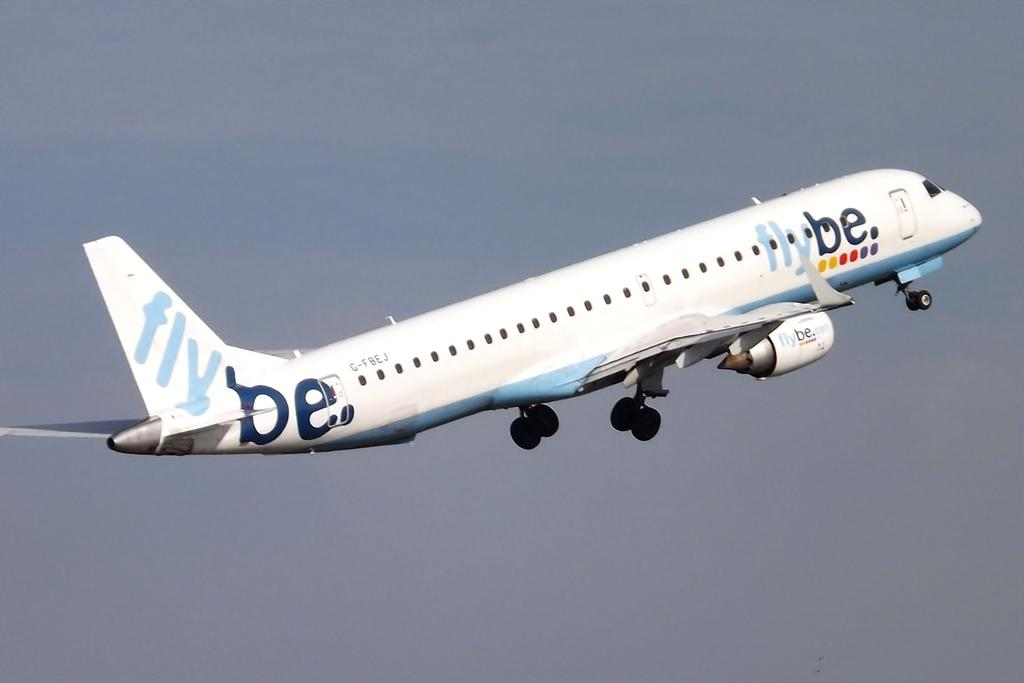What is the main subject of the image? The main subject of the image is an aeroplane. What is the aeroplane doing in the image? The aeroplane is flying in the sky. Who is the writer in the image? There is no writer present in the image; it features an aeroplane flying in the sky. What type of plantation can be seen in the image? There is no plantation present in the image; it features an aeroplane flying in the sky. 